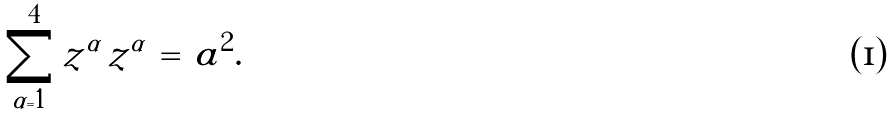Convert formula to latex. <formula><loc_0><loc_0><loc_500><loc_500>\sum _ { \alpha = 1 } ^ { 4 } z ^ { \alpha } \, z ^ { \alpha } \, = \, a ^ { 2 } .</formula> 